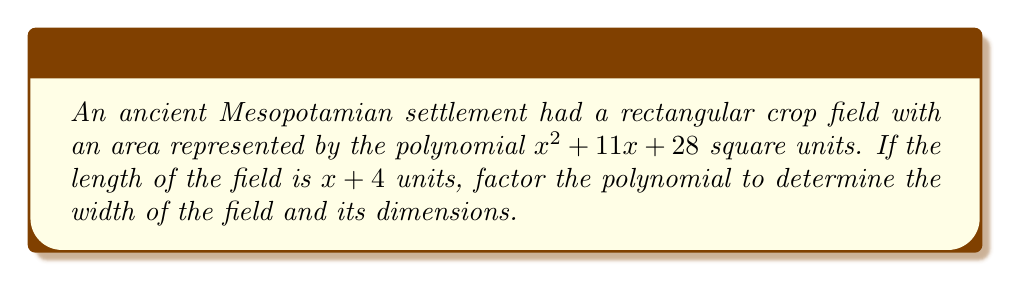Can you answer this question? To solve this problem, we need to factor the given polynomial and relate it to the dimensions of the field. Let's proceed step-by-step:

1) We are given that the area of the field is represented by $x^2 + 11x + 28$ square units.

2) We're also told that the length of the field is $x + 4$ units.

3) Since the field is rectangular, we can express its area as length × width:

   $$(x + 4)(width) = x^2 + 11x + 28$$

4) This means that the width of the field must be the other factor of the polynomial $x^2 + 11x + 28$.

5) To factor $x^2 + 11x + 28$, we need to find two numbers that multiply to give 28 and add up to 11.
   These numbers are 7 and 4.

6) We can rewrite the polynomial as:

   $$x^2 + 11x + 28 = x^2 + 7x + 4x + 28$$

7) Grouping these terms:

   $$(x^2 + 7x) + (4x + 28)$$
   $$x(x + 7) + 4(x + 7)$$
   $$(x + 4)(x + 7)$$

8) Therefore, the factored form of the polynomial is $(x + 4)(x + 7)$.

9) We already know that the length is $(x + 4)$, so the width must be $(x + 7)$.

10) The dimensions of the field are thus $(x + 4)$ units in length and $(x + 7)$ units in width.
Answer: The factored form of the polynomial is $(x + 4)(x + 7)$. The width of the field is $(x + 7)$ units, and the dimensions are $(x + 4)$ units in length and $(x + 7)$ units in width. 